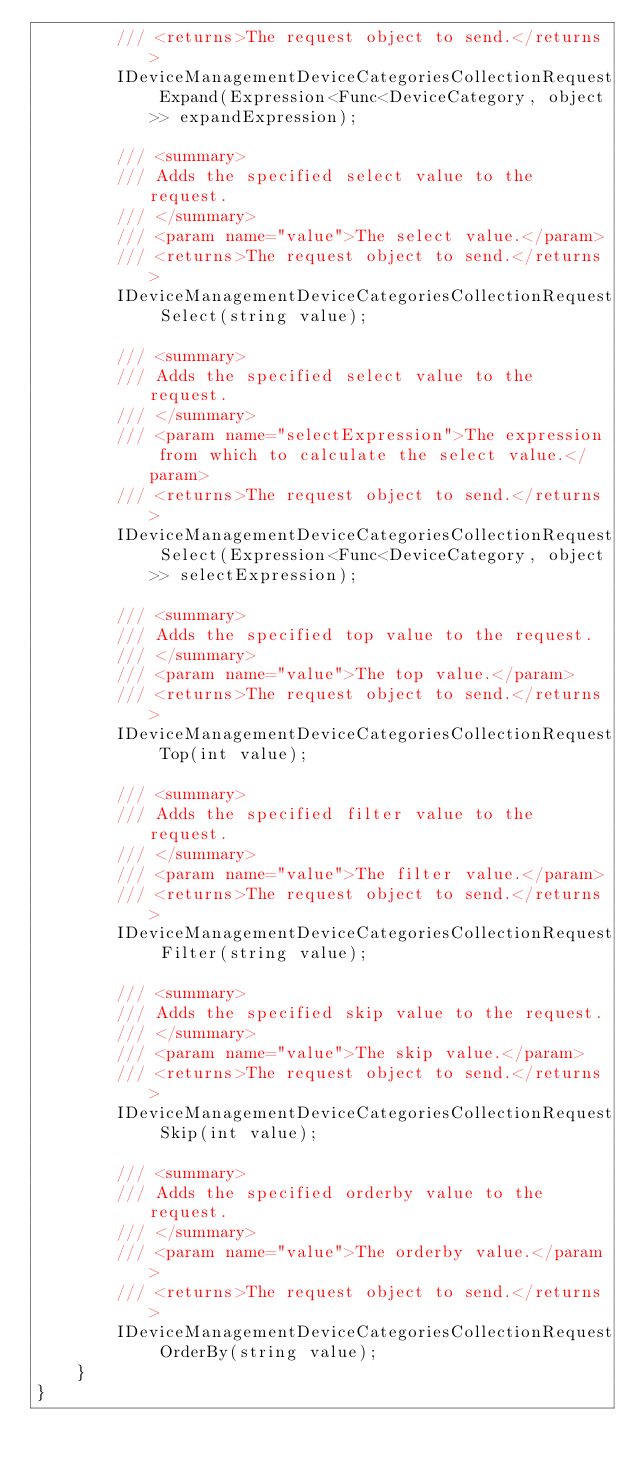Convert code to text. <code><loc_0><loc_0><loc_500><loc_500><_C#_>        /// <returns>The request object to send.</returns>
        IDeviceManagementDeviceCategoriesCollectionRequest Expand(Expression<Func<DeviceCategory, object>> expandExpression);

        /// <summary>
        /// Adds the specified select value to the request.
        /// </summary>
        /// <param name="value">The select value.</param>
        /// <returns>The request object to send.</returns>
        IDeviceManagementDeviceCategoriesCollectionRequest Select(string value);

        /// <summary>
        /// Adds the specified select value to the request.
        /// </summary>
        /// <param name="selectExpression">The expression from which to calculate the select value.</param>
        /// <returns>The request object to send.</returns>
        IDeviceManagementDeviceCategoriesCollectionRequest Select(Expression<Func<DeviceCategory, object>> selectExpression);

        /// <summary>
        /// Adds the specified top value to the request.
        /// </summary>
        /// <param name="value">The top value.</param>
        /// <returns>The request object to send.</returns>
        IDeviceManagementDeviceCategoriesCollectionRequest Top(int value);

        /// <summary>
        /// Adds the specified filter value to the request.
        /// </summary>
        /// <param name="value">The filter value.</param>
        /// <returns>The request object to send.</returns>
        IDeviceManagementDeviceCategoriesCollectionRequest Filter(string value);

        /// <summary>
        /// Adds the specified skip value to the request.
        /// </summary>
        /// <param name="value">The skip value.</param>
        /// <returns>The request object to send.</returns>
        IDeviceManagementDeviceCategoriesCollectionRequest Skip(int value);

        /// <summary>
        /// Adds the specified orderby value to the request.
        /// </summary>
        /// <param name="value">The orderby value.</param>
        /// <returns>The request object to send.</returns>
        IDeviceManagementDeviceCategoriesCollectionRequest OrderBy(string value);
    }
}
</code> 